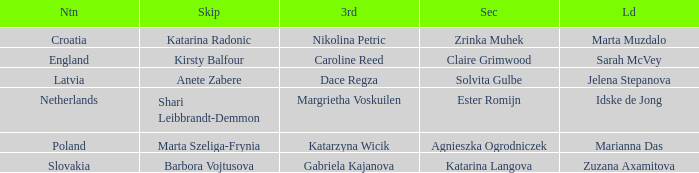Who is the Second with Nikolina Petric as Third? Zrinka Muhek. 